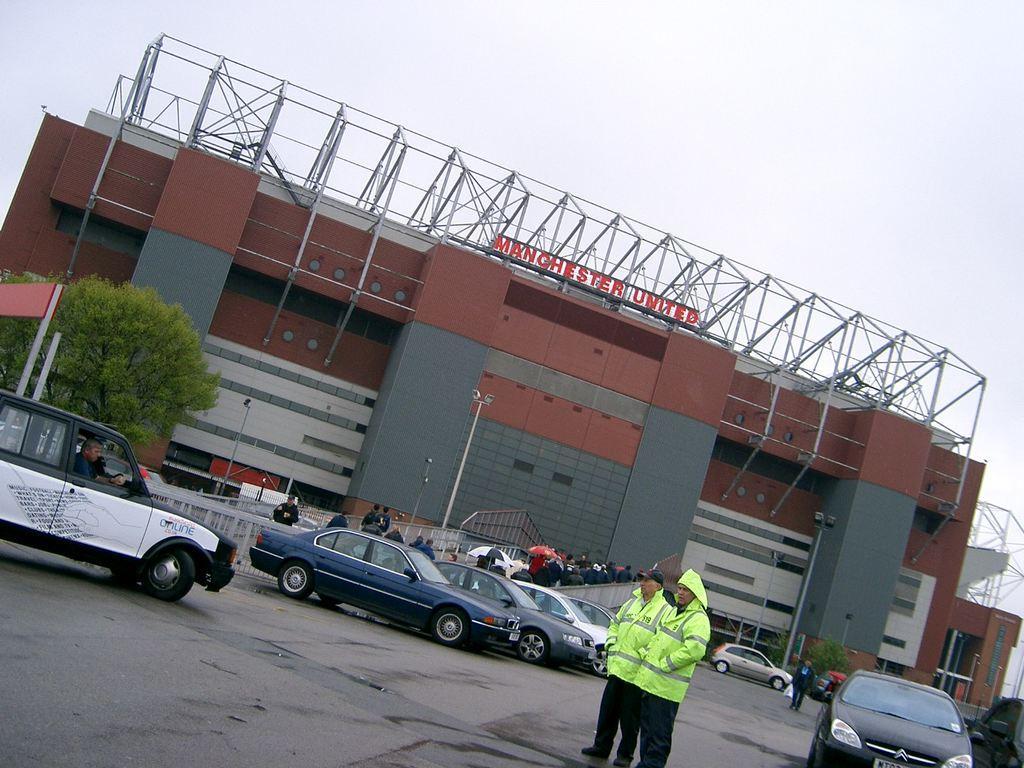Can you describe this image briefly? In the image we can see there are two men standing and they are wearing jackets. There are cars parked on the road and behind there are building and there are trees. 